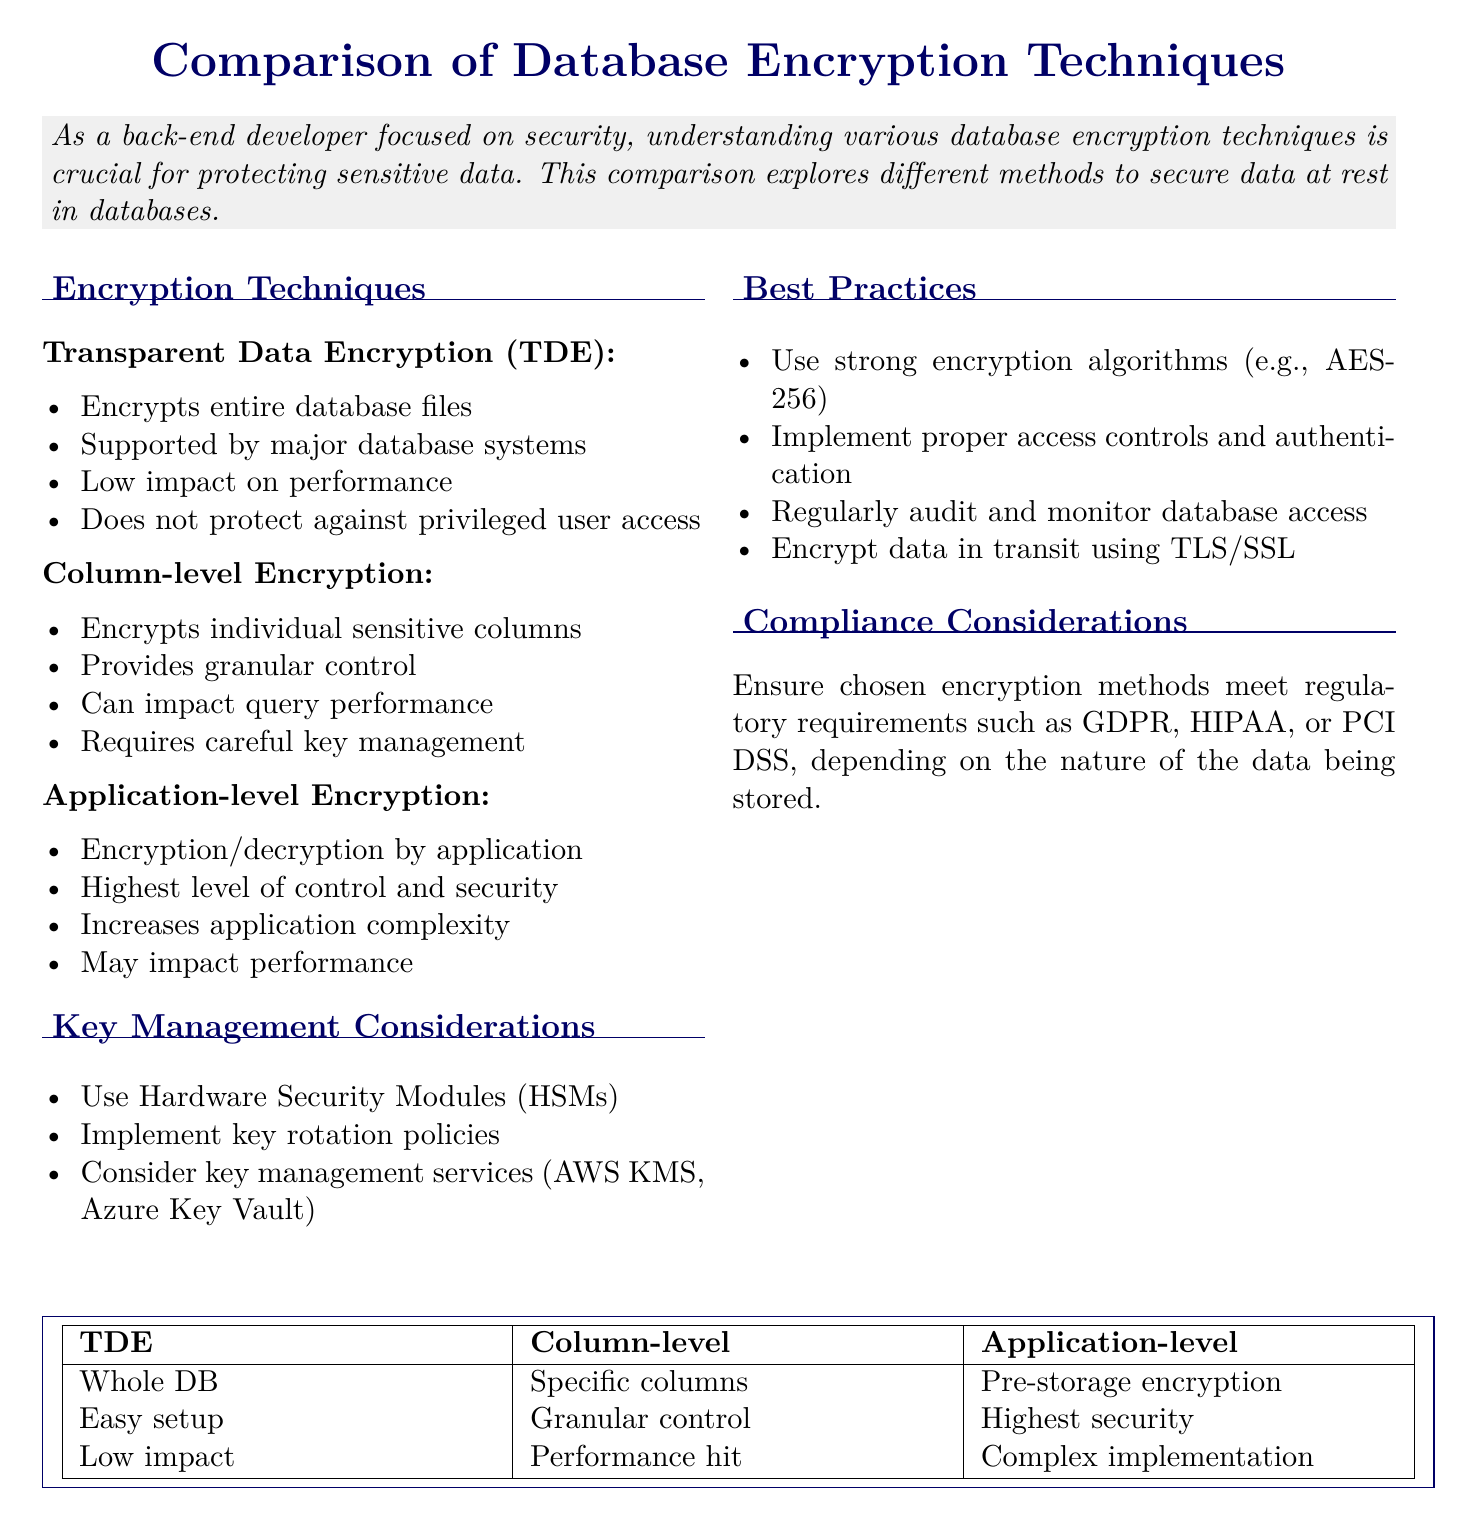what is the title of the document? The title of the document is clearly stated at the beginning, which is "Comparison of Database Encryption Techniques for Sensitive Data Storage."
Answer: Comparison of Database Encryption Techniques for Sensitive Data Storage what does TDE stand for? TDE is an acronym mentioned in the document under the encryption techniques section, which stands for "Transparent Data Encryption."
Answer: Transparent Data Encryption which encryption technique encrypts individual columns? The document lists different encryption techniques, and Column-level Encryption is specifically mentioned as the technique that encrypts individual columns.
Answer: Column-level Encryption what is a key management service mentioned in the document? The document references key management services as part of key management considerations, specifically naming AWS KMS and Azure Key Vault.
Answer: AWS KMS or Azure Key Vault what is the benefit of application-level encryption? The document states that application-level encryption offers the "highest level of control and security" compared to other techniques.
Answer: highest level of control and security what does the document recommend for encryption algorithms? In the best practices section, it is advised to use strong encryption algorithms which specifically mentions AES-256.
Answer: AES-256 which regulatory requirements should encryption methods meet according to the document? The compliance considerations section indicates that chosen encryption methods must meet requirements like GDPR and HIPAA.
Answer: GDPR, HIPAA, or PCI DSS what is one impact of column-level encryption mentioned? The document notes that a potential drawback of column-level encryption is that it "can impact query performance."
Answer: can impact query performance 